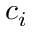<formula> <loc_0><loc_0><loc_500><loc_500>c _ { i }</formula> 